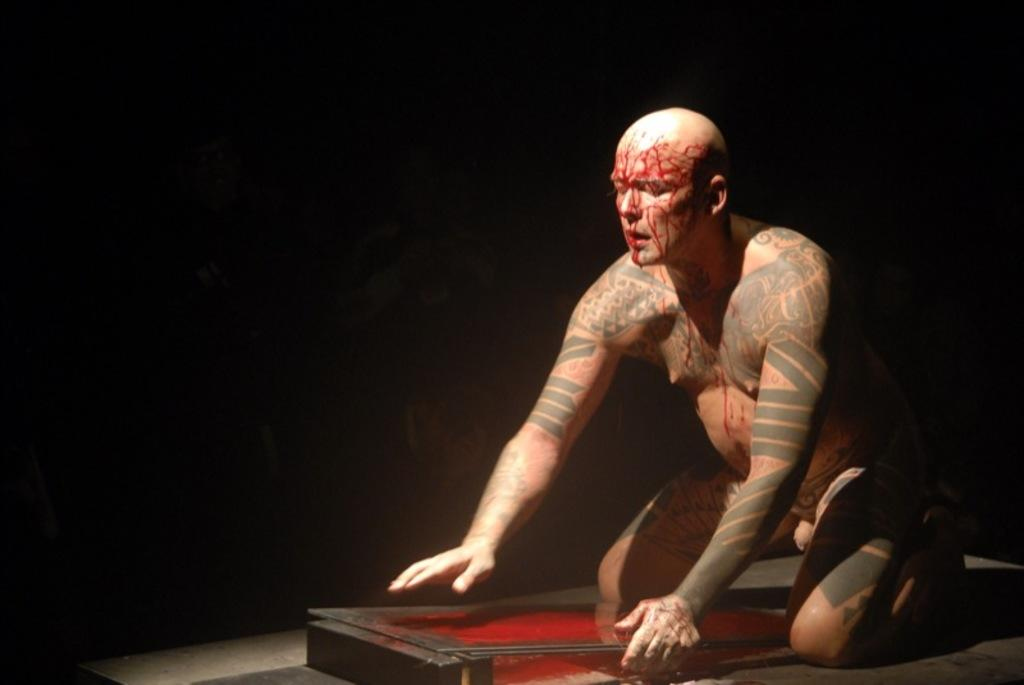Who is the main subject in the image? There is a man in the center of the image. What object is present in front of the man? There is a mirror in front of the man. What type of tree can be seen growing in the mirror? There is no tree visible in the mirror or in the image. 